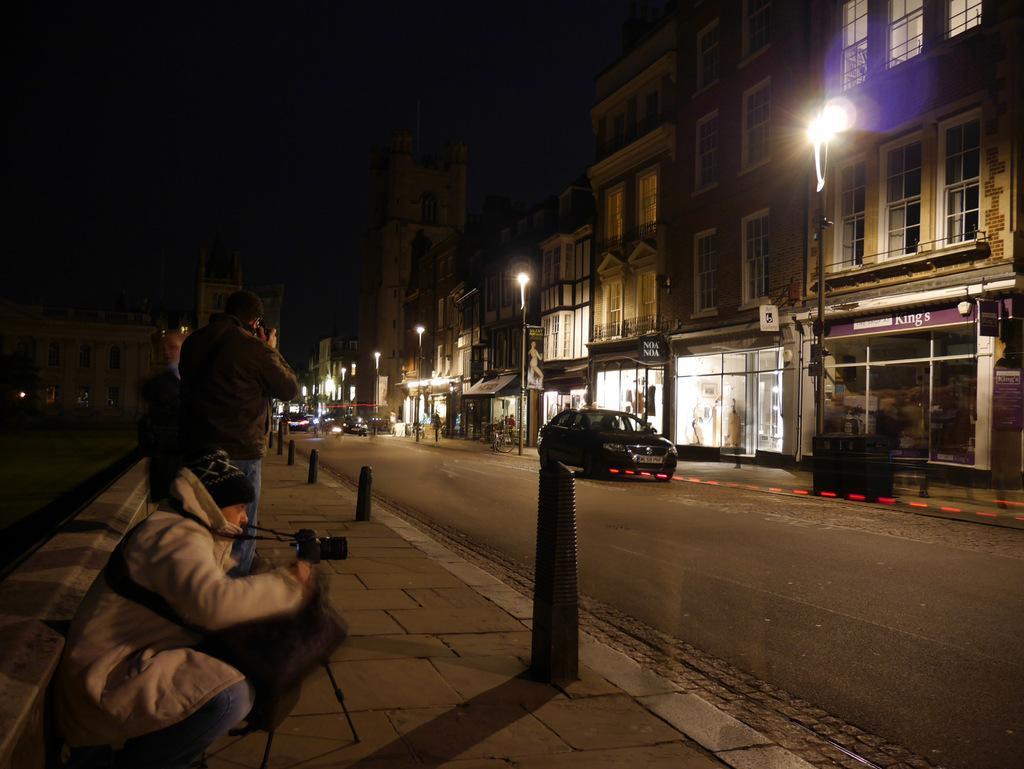Could you give a brief overview of what you see in this image? In this image, we can see people on the sidewalk and one of them is wearing a coat, cap and holding a camera and there are divider cones. In the background, there are buildings, lights, poles and vehicles. At the bottom, there is road. 